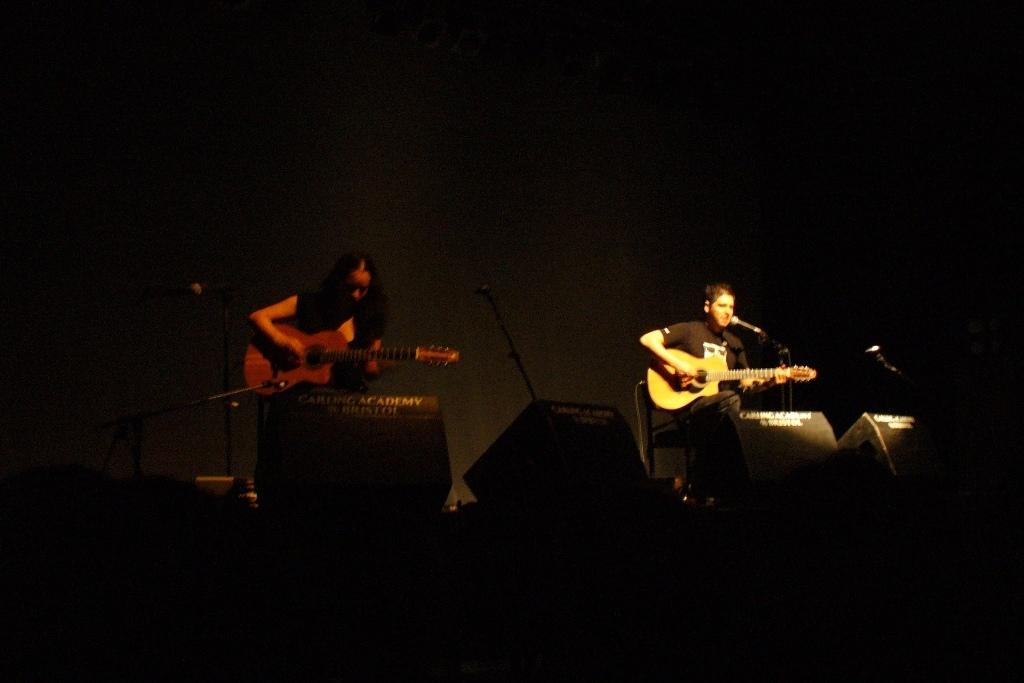How many people are in the image? There are two people in the image. What are the two people doing in the image? The two people are playing musical instruments. What type of butter can be seen on the station in the image? There is no butter or station present in the image; it features two people playing musical instruments. 